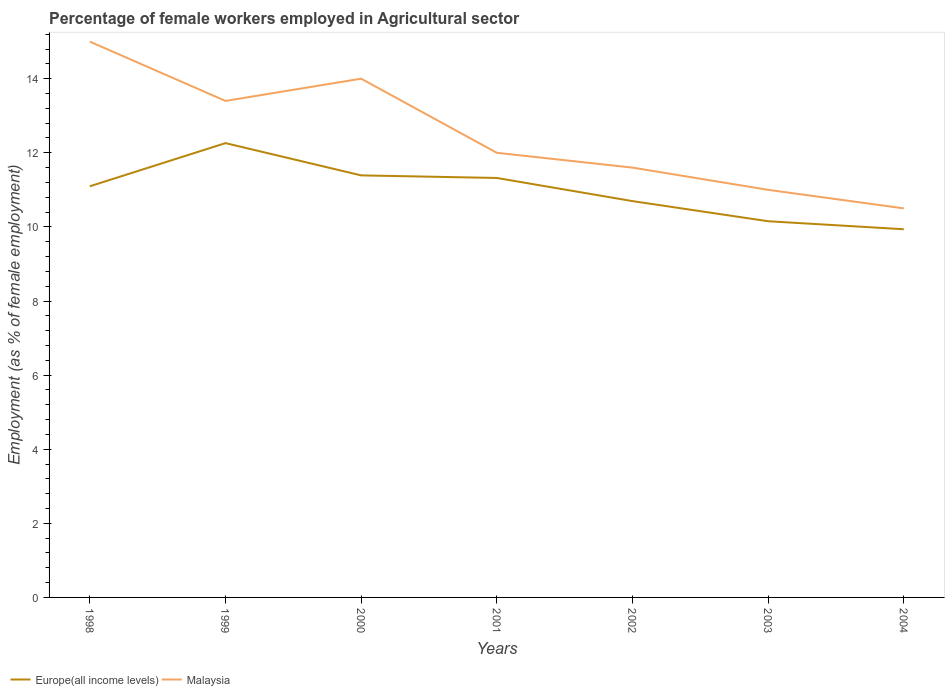Does the line corresponding to Europe(all income levels) intersect with the line corresponding to Malaysia?
Give a very brief answer. No. Is the number of lines equal to the number of legend labels?
Ensure brevity in your answer.  Yes. Across all years, what is the maximum percentage of females employed in Agricultural sector in Europe(all income levels)?
Give a very brief answer. 9.94. In which year was the percentage of females employed in Agricultural sector in Europe(all income levels) maximum?
Provide a succinct answer. 2004. What is the total percentage of females employed in Agricultural sector in Malaysia in the graph?
Provide a succinct answer. 1.4. What is the difference between the highest and the second highest percentage of females employed in Agricultural sector in Malaysia?
Offer a very short reply. 4.5. What is the difference between the highest and the lowest percentage of females employed in Agricultural sector in Malaysia?
Your answer should be compact. 3. Is the percentage of females employed in Agricultural sector in Europe(all income levels) strictly greater than the percentage of females employed in Agricultural sector in Malaysia over the years?
Offer a terse response. Yes. How many years are there in the graph?
Keep it short and to the point. 7. What is the difference between two consecutive major ticks on the Y-axis?
Offer a very short reply. 2. Does the graph contain any zero values?
Give a very brief answer. No. Where does the legend appear in the graph?
Give a very brief answer. Bottom left. How many legend labels are there?
Give a very brief answer. 2. How are the legend labels stacked?
Offer a very short reply. Horizontal. What is the title of the graph?
Your answer should be very brief. Percentage of female workers employed in Agricultural sector. Does "Mongolia" appear as one of the legend labels in the graph?
Offer a terse response. No. What is the label or title of the X-axis?
Your answer should be very brief. Years. What is the label or title of the Y-axis?
Offer a very short reply. Employment (as % of female employment). What is the Employment (as % of female employment) in Europe(all income levels) in 1998?
Your answer should be very brief. 11.1. What is the Employment (as % of female employment) of Malaysia in 1998?
Keep it short and to the point. 15. What is the Employment (as % of female employment) in Europe(all income levels) in 1999?
Ensure brevity in your answer.  12.26. What is the Employment (as % of female employment) of Malaysia in 1999?
Your response must be concise. 13.4. What is the Employment (as % of female employment) in Europe(all income levels) in 2000?
Provide a succinct answer. 11.39. What is the Employment (as % of female employment) in Europe(all income levels) in 2001?
Give a very brief answer. 11.32. What is the Employment (as % of female employment) in Europe(all income levels) in 2002?
Your response must be concise. 10.7. What is the Employment (as % of female employment) of Malaysia in 2002?
Your answer should be very brief. 11.6. What is the Employment (as % of female employment) in Europe(all income levels) in 2003?
Give a very brief answer. 10.15. What is the Employment (as % of female employment) of Europe(all income levels) in 2004?
Your answer should be very brief. 9.94. Across all years, what is the maximum Employment (as % of female employment) of Europe(all income levels)?
Offer a very short reply. 12.26. Across all years, what is the maximum Employment (as % of female employment) of Malaysia?
Your response must be concise. 15. Across all years, what is the minimum Employment (as % of female employment) of Europe(all income levels)?
Your answer should be very brief. 9.94. What is the total Employment (as % of female employment) in Europe(all income levels) in the graph?
Keep it short and to the point. 76.85. What is the total Employment (as % of female employment) in Malaysia in the graph?
Your response must be concise. 87.5. What is the difference between the Employment (as % of female employment) of Europe(all income levels) in 1998 and that in 1999?
Offer a terse response. -1.16. What is the difference between the Employment (as % of female employment) in Europe(all income levels) in 1998 and that in 2000?
Keep it short and to the point. -0.29. What is the difference between the Employment (as % of female employment) of Europe(all income levels) in 1998 and that in 2001?
Your answer should be very brief. -0.22. What is the difference between the Employment (as % of female employment) of Europe(all income levels) in 1998 and that in 2002?
Your response must be concise. 0.4. What is the difference between the Employment (as % of female employment) in Europe(all income levels) in 1998 and that in 2003?
Give a very brief answer. 0.94. What is the difference between the Employment (as % of female employment) of Europe(all income levels) in 1998 and that in 2004?
Give a very brief answer. 1.16. What is the difference between the Employment (as % of female employment) of Europe(all income levels) in 1999 and that in 2000?
Provide a succinct answer. 0.87. What is the difference between the Employment (as % of female employment) in Malaysia in 1999 and that in 2000?
Keep it short and to the point. -0.6. What is the difference between the Employment (as % of female employment) of Europe(all income levels) in 1999 and that in 2001?
Your response must be concise. 0.94. What is the difference between the Employment (as % of female employment) of Malaysia in 1999 and that in 2001?
Your answer should be very brief. 1.4. What is the difference between the Employment (as % of female employment) in Europe(all income levels) in 1999 and that in 2002?
Make the answer very short. 1.56. What is the difference between the Employment (as % of female employment) of Europe(all income levels) in 1999 and that in 2003?
Provide a succinct answer. 2.11. What is the difference between the Employment (as % of female employment) of Malaysia in 1999 and that in 2003?
Offer a terse response. 2.4. What is the difference between the Employment (as % of female employment) of Europe(all income levels) in 1999 and that in 2004?
Provide a short and direct response. 2.32. What is the difference between the Employment (as % of female employment) of Europe(all income levels) in 2000 and that in 2001?
Offer a terse response. 0.07. What is the difference between the Employment (as % of female employment) in Malaysia in 2000 and that in 2001?
Keep it short and to the point. 2. What is the difference between the Employment (as % of female employment) of Europe(all income levels) in 2000 and that in 2002?
Offer a very short reply. 0.69. What is the difference between the Employment (as % of female employment) in Malaysia in 2000 and that in 2002?
Offer a very short reply. 2.4. What is the difference between the Employment (as % of female employment) of Europe(all income levels) in 2000 and that in 2003?
Ensure brevity in your answer.  1.24. What is the difference between the Employment (as % of female employment) in Europe(all income levels) in 2000 and that in 2004?
Keep it short and to the point. 1.45. What is the difference between the Employment (as % of female employment) of Europe(all income levels) in 2001 and that in 2002?
Your response must be concise. 0.62. What is the difference between the Employment (as % of female employment) in Malaysia in 2001 and that in 2002?
Make the answer very short. 0.4. What is the difference between the Employment (as % of female employment) in Europe(all income levels) in 2001 and that in 2003?
Your answer should be compact. 1.17. What is the difference between the Employment (as % of female employment) of Malaysia in 2001 and that in 2003?
Offer a very short reply. 1. What is the difference between the Employment (as % of female employment) in Europe(all income levels) in 2001 and that in 2004?
Your answer should be compact. 1.38. What is the difference between the Employment (as % of female employment) in Europe(all income levels) in 2002 and that in 2003?
Offer a terse response. 0.54. What is the difference between the Employment (as % of female employment) of Europe(all income levels) in 2002 and that in 2004?
Ensure brevity in your answer.  0.76. What is the difference between the Employment (as % of female employment) of Europe(all income levels) in 2003 and that in 2004?
Keep it short and to the point. 0.22. What is the difference between the Employment (as % of female employment) in Malaysia in 2003 and that in 2004?
Ensure brevity in your answer.  0.5. What is the difference between the Employment (as % of female employment) in Europe(all income levels) in 1998 and the Employment (as % of female employment) in Malaysia in 1999?
Give a very brief answer. -2.3. What is the difference between the Employment (as % of female employment) of Europe(all income levels) in 1998 and the Employment (as % of female employment) of Malaysia in 2000?
Provide a short and direct response. -2.9. What is the difference between the Employment (as % of female employment) in Europe(all income levels) in 1998 and the Employment (as % of female employment) in Malaysia in 2001?
Your response must be concise. -0.9. What is the difference between the Employment (as % of female employment) of Europe(all income levels) in 1998 and the Employment (as % of female employment) of Malaysia in 2002?
Offer a very short reply. -0.5. What is the difference between the Employment (as % of female employment) of Europe(all income levels) in 1998 and the Employment (as % of female employment) of Malaysia in 2003?
Make the answer very short. 0.1. What is the difference between the Employment (as % of female employment) in Europe(all income levels) in 1998 and the Employment (as % of female employment) in Malaysia in 2004?
Give a very brief answer. 0.6. What is the difference between the Employment (as % of female employment) in Europe(all income levels) in 1999 and the Employment (as % of female employment) in Malaysia in 2000?
Ensure brevity in your answer.  -1.74. What is the difference between the Employment (as % of female employment) in Europe(all income levels) in 1999 and the Employment (as % of female employment) in Malaysia in 2001?
Make the answer very short. 0.26. What is the difference between the Employment (as % of female employment) in Europe(all income levels) in 1999 and the Employment (as % of female employment) in Malaysia in 2002?
Provide a short and direct response. 0.66. What is the difference between the Employment (as % of female employment) in Europe(all income levels) in 1999 and the Employment (as % of female employment) in Malaysia in 2003?
Your answer should be very brief. 1.26. What is the difference between the Employment (as % of female employment) of Europe(all income levels) in 1999 and the Employment (as % of female employment) of Malaysia in 2004?
Your response must be concise. 1.76. What is the difference between the Employment (as % of female employment) of Europe(all income levels) in 2000 and the Employment (as % of female employment) of Malaysia in 2001?
Offer a very short reply. -0.61. What is the difference between the Employment (as % of female employment) in Europe(all income levels) in 2000 and the Employment (as % of female employment) in Malaysia in 2002?
Provide a succinct answer. -0.21. What is the difference between the Employment (as % of female employment) in Europe(all income levels) in 2000 and the Employment (as % of female employment) in Malaysia in 2003?
Make the answer very short. 0.39. What is the difference between the Employment (as % of female employment) in Europe(all income levels) in 2000 and the Employment (as % of female employment) in Malaysia in 2004?
Offer a very short reply. 0.89. What is the difference between the Employment (as % of female employment) of Europe(all income levels) in 2001 and the Employment (as % of female employment) of Malaysia in 2002?
Offer a very short reply. -0.28. What is the difference between the Employment (as % of female employment) of Europe(all income levels) in 2001 and the Employment (as % of female employment) of Malaysia in 2003?
Offer a very short reply. 0.32. What is the difference between the Employment (as % of female employment) of Europe(all income levels) in 2001 and the Employment (as % of female employment) of Malaysia in 2004?
Your answer should be compact. 0.82. What is the difference between the Employment (as % of female employment) in Europe(all income levels) in 2002 and the Employment (as % of female employment) in Malaysia in 2003?
Your answer should be very brief. -0.3. What is the difference between the Employment (as % of female employment) of Europe(all income levels) in 2002 and the Employment (as % of female employment) of Malaysia in 2004?
Offer a terse response. 0.2. What is the difference between the Employment (as % of female employment) in Europe(all income levels) in 2003 and the Employment (as % of female employment) in Malaysia in 2004?
Make the answer very short. -0.35. What is the average Employment (as % of female employment) in Europe(all income levels) per year?
Keep it short and to the point. 10.98. In the year 1998, what is the difference between the Employment (as % of female employment) in Europe(all income levels) and Employment (as % of female employment) in Malaysia?
Offer a terse response. -3.9. In the year 1999, what is the difference between the Employment (as % of female employment) of Europe(all income levels) and Employment (as % of female employment) of Malaysia?
Your answer should be compact. -1.14. In the year 2000, what is the difference between the Employment (as % of female employment) of Europe(all income levels) and Employment (as % of female employment) of Malaysia?
Ensure brevity in your answer.  -2.61. In the year 2001, what is the difference between the Employment (as % of female employment) in Europe(all income levels) and Employment (as % of female employment) in Malaysia?
Your answer should be compact. -0.68. In the year 2002, what is the difference between the Employment (as % of female employment) in Europe(all income levels) and Employment (as % of female employment) in Malaysia?
Provide a short and direct response. -0.9. In the year 2003, what is the difference between the Employment (as % of female employment) in Europe(all income levels) and Employment (as % of female employment) in Malaysia?
Make the answer very short. -0.85. In the year 2004, what is the difference between the Employment (as % of female employment) in Europe(all income levels) and Employment (as % of female employment) in Malaysia?
Your answer should be very brief. -0.56. What is the ratio of the Employment (as % of female employment) of Europe(all income levels) in 1998 to that in 1999?
Offer a terse response. 0.91. What is the ratio of the Employment (as % of female employment) in Malaysia in 1998 to that in 1999?
Give a very brief answer. 1.12. What is the ratio of the Employment (as % of female employment) in Europe(all income levels) in 1998 to that in 2000?
Your answer should be very brief. 0.97. What is the ratio of the Employment (as % of female employment) of Malaysia in 1998 to that in 2000?
Provide a succinct answer. 1.07. What is the ratio of the Employment (as % of female employment) in Europe(all income levels) in 1998 to that in 2001?
Provide a succinct answer. 0.98. What is the ratio of the Employment (as % of female employment) of Europe(all income levels) in 1998 to that in 2002?
Give a very brief answer. 1.04. What is the ratio of the Employment (as % of female employment) in Malaysia in 1998 to that in 2002?
Your response must be concise. 1.29. What is the ratio of the Employment (as % of female employment) of Europe(all income levels) in 1998 to that in 2003?
Offer a very short reply. 1.09. What is the ratio of the Employment (as % of female employment) in Malaysia in 1998 to that in 2003?
Keep it short and to the point. 1.36. What is the ratio of the Employment (as % of female employment) in Europe(all income levels) in 1998 to that in 2004?
Your answer should be very brief. 1.12. What is the ratio of the Employment (as % of female employment) in Malaysia in 1998 to that in 2004?
Your answer should be very brief. 1.43. What is the ratio of the Employment (as % of female employment) in Europe(all income levels) in 1999 to that in 2000?
Give a very brief answer. 1.08. What is the ratio of the Employment (as % of female employment) in Malaysia in 1999 to that in 2000?
Ensure brevity in your answer.  0.96. What is the ratio of the Employment (as % of female employment) in Europe(all income levels) in 1999 to that in 2001?
Offer a terse response. 1.08. What is the ratio of the Employment (as % of female employment) in Malaysia in 1999 to that in 2001?
Provide a short and direct response. 1.12. What is the ratio of the Employment (as % of female employment) of Europe(all income levels) in 1999 to that in 2002?
Your answer should be very brief. 1.15. What is the ratio of the Employment (as % of female employment) in Malaysia in 1999 to that in 2002?
Your answer should be compact. 1.16. What is the ratio of the Employment (as % of female employment) of Europe(all income levels) in 1999 to that in 2003?
Provide a succinct answer. 1.21. What is the ratio of the Employment (as % of female employment) in Malaysia in 1999 to that in 2003?
Your answer should be very brief. 1.22. What is the ratio of the Employment (as % of female employment) in Europe(all income levels) in 1999 to that in 2004?
Keep it short and to the point. 1.23. What is the ratio of the Employment (as % of female employment) in Malaysia in 1999 to that in 2004?
Your answer should be very brief. 1.28. What is the ratio of the Employment (as % of female employment) in Europe(all income levels) in 2000 to that in 2001?
Your response must be concise. 1.01. What is the ratio of the Employment (as % of female employment) of Malaysia in 2000 to that in 2001?
Give a very brief answer. 1.17. What is the ratio of the Employment (as % of female employment) in Europe(all income levels) in 2000 to that in 2002?
Ensure brevity in your answer.  1.06. What is the ratio of the Employment (as % of female employment) in Malaysia in 2000 to that in 2002?
Make the answer very short. 1.21. What is the ratio of the Employment (as % of female employment) of Europe(all income levels) in 2000 to that in 2003?
Ensure brevity in your answer.  1.12. What is the ratio of the Employment (as % of female employment) of Malaysia in 2000 to that in 2003?
Keep it short and to the point. 1.27. What is the ratio of the Employment (as % of female employment) in Europe(all income levels) in 2000 to that in 2004?
Give a very brief answer. 1.15. What is the ratio of the Employment (as % of female employment) in Europe(all income levels) in 2001 to that in 2002?
Provide a succinct answer. 1.06. What is the ratio of the Employment (as % of female employment) in Malaysia in 2001 to that in 2002?
Your answer should be compact. 1.03. What is the ratio of the Employment (as % of female employment) in Europe(all income levels) in 2001 to that in 2003?
Your answer should be compact. 1.11. What is the ratio of the Employment (as % of female employment) in Europe(all income levels) in 2001 to that in 2004?
Your answer should be very brief. 1.14. What is the ratio of the Employment (as % of female employment) of Europe(all income levels) in 2002 to that in 2003?
Your answer should be compact. 1.05. What is the ratio of the Employment (as % of female employment) in Malaysia in 2002 to that in 2003?
Ensure brevity in your answer.  1.05. What is the ratio of the Employment (as % of female employment) of Europe(all income levels) in 2002 to that in 2004?
Offer a very short reply. 1.08. What is the ratio of the Employment (as % of female employment) of Malaysia in 2002 to that in 2004?
Make the answer very short. 1.1. What is the ratio of the Employment (as % of female employment) in Europe(all income levels) in 2003 to that in 2004?
Your response must be concise. 1.02. What is the ratio of the Employment (as % of female employment) in Malaysia in 2003 to that in 2004?
Offer a terse response. 1.05. What is the difference between the highest and the second highest Employment (as % of female employment) of Europe(all income levels)?
Provide a succinct answer. 0.87. What is the difference between the highest and the second highest Employment (as % of female employment) in Malaysia?
Ensure brevity in your answer.  1. What is the difference between the highest and the lowest Employment (as % of female employment) in Europe(all income levels)?
Your answer should be compact. 2.32. 